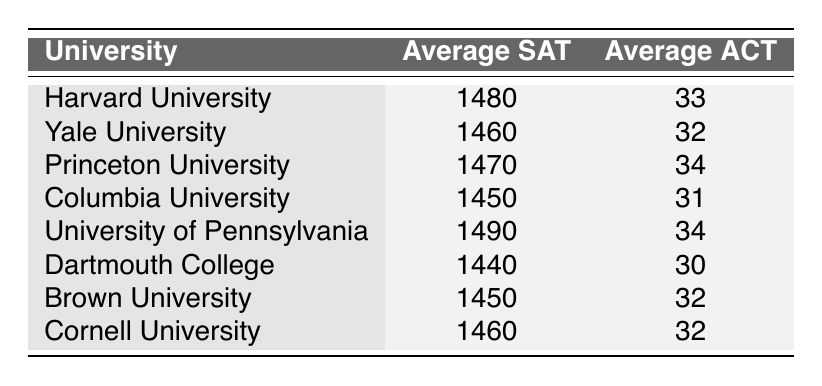What is the average SAT score for Princeton University? The table shows the Average SAT score for each university separately. For Princeton University, the score listed is 1470.
Answer: 1470 Which Ivy League school has the highest Average ACT score? By looking at the Average ACT scores for all universities in the table, we see Princeton University and the University of Pennsylvania both have an Average ACT score of 34, which is the highest compared to others.
Answer: Princeton University and University of Pennsylvania Is the Average SAT score for Yale University higher than that of Dartmouth College? The Average SAT score for Yale University is 1460 and for Dartmouth College, it is 1440. Since 1460 is greater than 1440, the statement is true.
Answer: Yes What is the difference between the highest and lowest Average SAT scores in the table? To find the difference, we first identify the highest Average SAT score, which is 1490 (University of Pennsylvania), and the lowest, which is 1440 (Dartmouth College). The difference is calculated as 1490 - 1440 = 50.
Answer: 50 What is the average ACT score for the Ivy League schools listed in the table? To calculate the average, we add all Average ACT scores: 33 + 32 + 34 + 31 + 34 + 30 + 32 + 32 = 256. The total number of schools is 8, so the average is 256/8 = 32.
Answer: 32 What percentage of Ivy League schools have an Average SAT score above 1450? The schools with an Average SAT above 1450 are Harvard, Yale, Princeton, and Penn, totaling 4 schools out of 8. The percentage is (4/8) * 100 = 50%.
Answer: 50% Is it true that all Ivy League schools listed have an Average SAT score of at least 1400? Looking at all the Average SAT scores, the lowest score is 1440 from Dartmouth College. Since all scores are above 1400, the statement is true.
Answer: Yes Which universities have an Average ACT score lower than 32? By reviewing the Average ACT scores, Dartmouth College has an Average ACT score of 30 and Columbia University has an Average ACT score of 31. Both scores are lower than 32.
Answer: Dartmouth College and Columbia University 